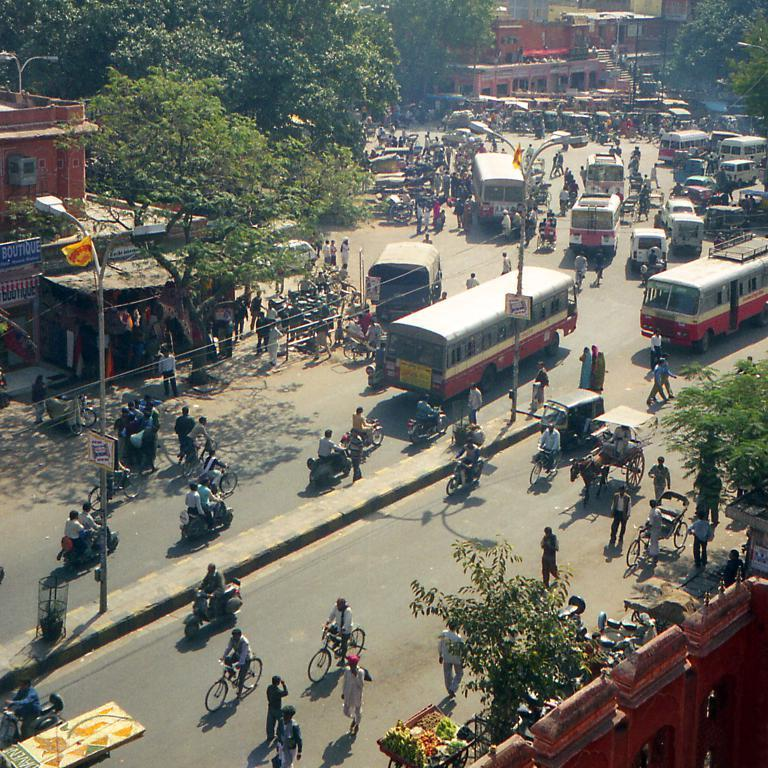Provide a one-sentence caption for the provided image. A blue sign for a boutique can be seen on the left side of the street. 